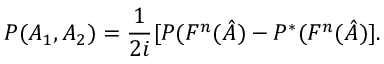Convert formula to latex. <formula><loc_0><loc_0><loc_500><loc_500>P ( A _ { 1 } , A _ { 2 } ) = \frac { 1 } { 2 i } [ P ( F ^ { n } ( \hat { A } ) - P ^ { \ast } ( F ^ { n } ( \hat { A } ) ] .</formula> 